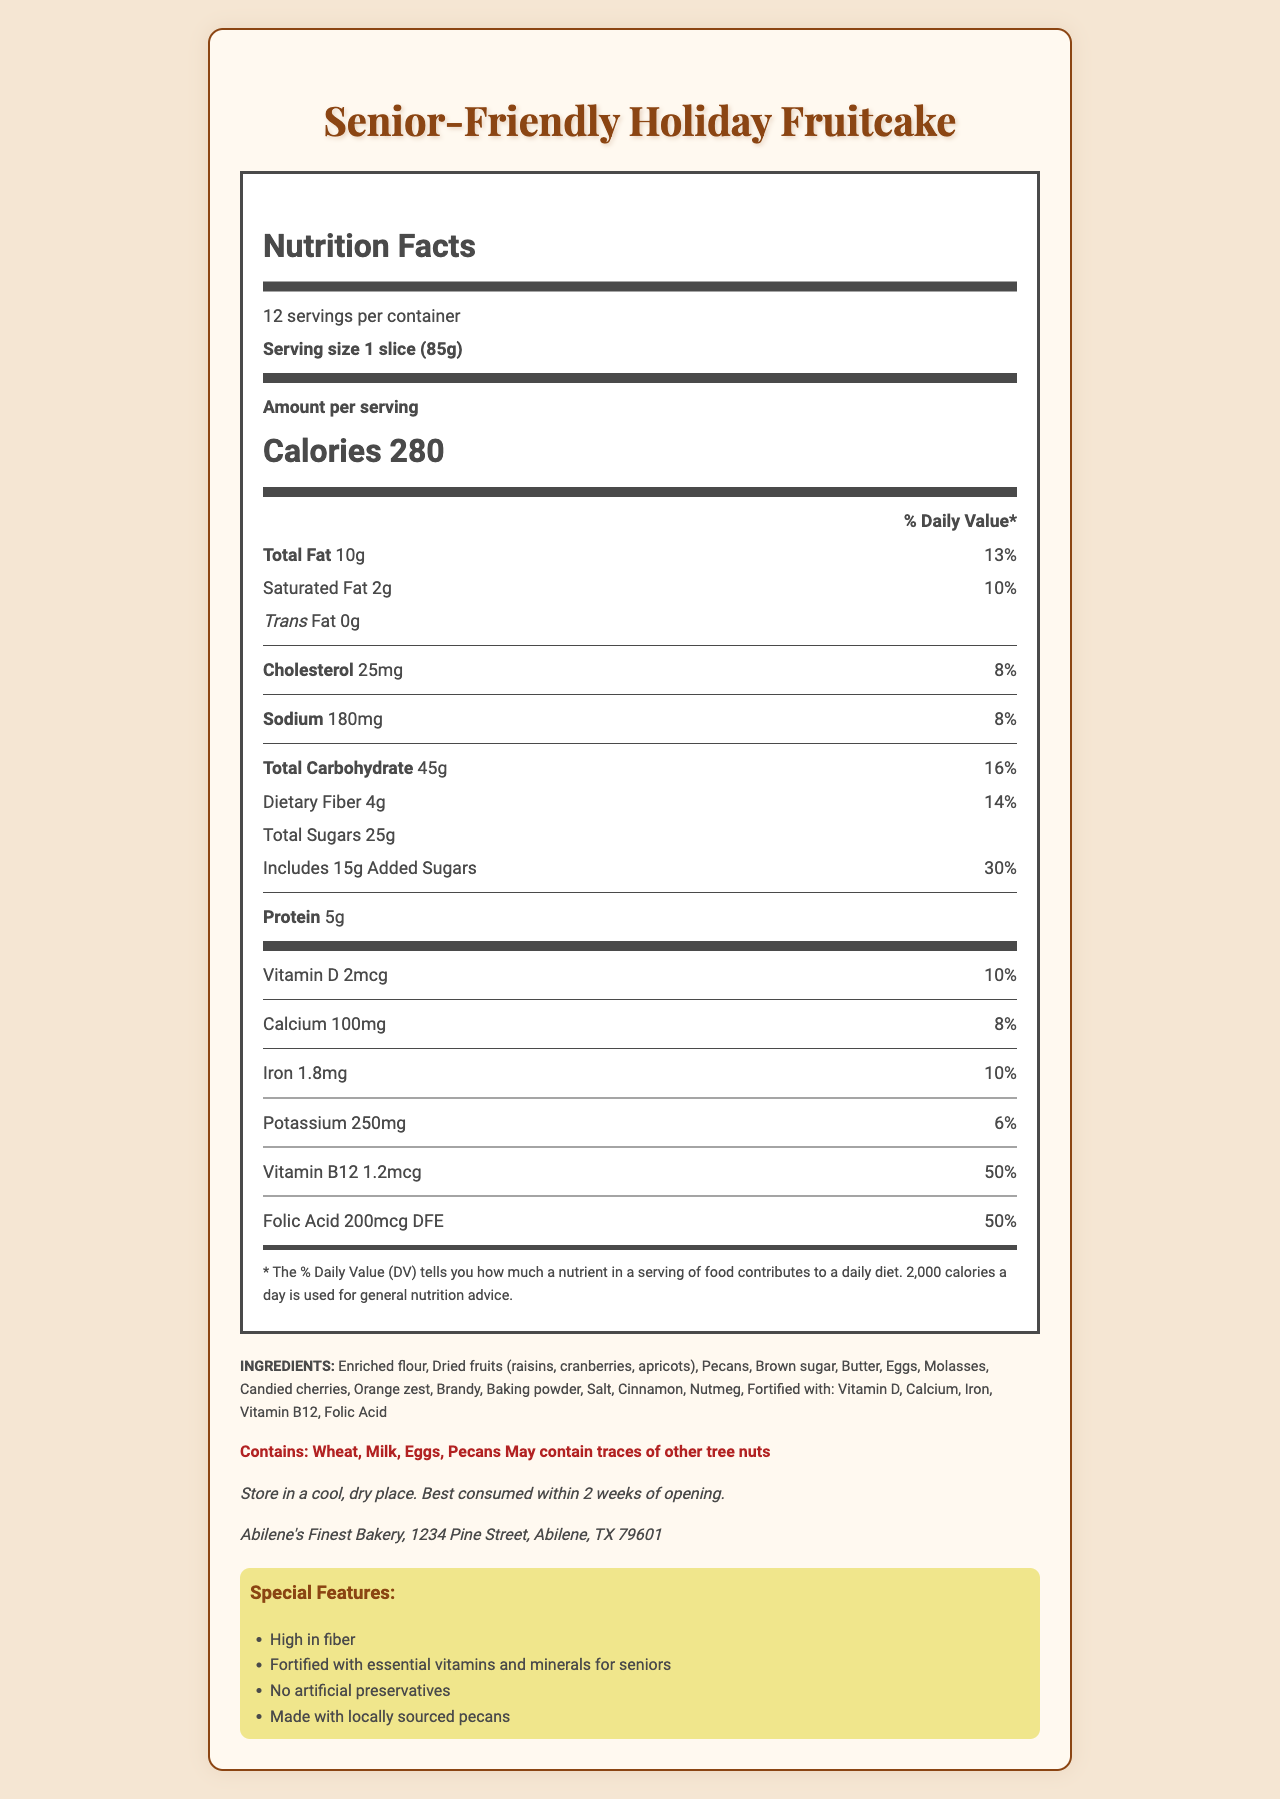what is the serving size? The serving size is noted in the nutrition facts section as "1 slice (85g)".
Answer: 1 slice (85g) how many servings are there per container? The document specifies that there are 12 servings per container.
Answer: 12 how much dietary fiber is in each serving? The nutrition label lists 4g of dietary fiber per serving.
Answer: 4g what is the daily value percentage of Vitamin B12 per serving? The nutrition label shows that Vitamin B12 has a daily value percentage of 50%.
Answer: 50% what are the allergens mentioned? These allergens are listed in the allergens section.
Answer: Wheat, Milk, Eggs, Pecans; May contain traces of other tree nuts how many calories are in each serving? A. 220 B. 250 C. 280 D. 300 The nutrition facts show that each serving contains 280 calories.
Answer: C. 280 what is the amount of calcium per serving? A. 100mg B. 150mg C. 200mg D. 250mg The nutrition label lists calcium as 100mg per serving.
Answer: A. 100mg is this fruitcake made with locally sourced pecans? The special features section notes that the fruitcake is made with locally sourced pecans.
Answer: Yes can this product be stored in a refrigerator? The document only mentions storing in a cool, dry place, not specifically a refrigerator.
Answer: Not enough information what is the total amount of added sugars per serving? The nutrition facts indicate that there are 15g of added sugars per serving.
Answer: 15g please summarize the main features of this document The document mainly describes the nutritional content, ingredients, allergens, and special features of the "Senior-Friendly Holiday Fruitcake," designed for senior demographics with added health benefits like fiber and fortified vitamins.
Answer: The document provides the nutrition facts for the "Senior-Friendly Holiday Fruitcake." Each serving is 85g with 280 calories. It highlights being high in fiber and fortified with essential vitamins (Vitamin D, Calcium, Iron, Vitamin B12, Folic Acid). It specifies the ingredients and allergens and gives storage instructions. The fruitcake is noted for no artificial preservatives and using locally sourced pecans. The manufacturer is listed as Abilene's Finest Bakery in Abilene, Texas. what's the total amount of sugars (natural + added) in one serving? The nutrition facts reveal that there are 25g of total sugars per serving.
Answer: 25g how much protein does each serving have? The document states that each serving has 5g of protein.
Answer: 5g what is the daily value percentage for sodium? The nutrition label states that the daily value percentage for sodium is 8%.
Answer: 8% what vitamins and minerals are specifically mentioned as added/fortified in this fruitcake? The special features section lists these vitamins and minerals as added/fortified for seniors.
Answer: Vitamin D, Calcium, Iron, Vitamin B12, Folic Acid 